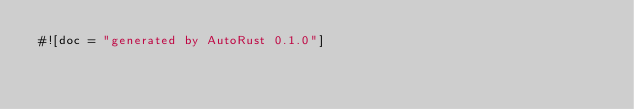<code> <loc_0><loc_0><loc_500><loc_500><_Rust_>#![doc = "generated by AutoRust 0.1.0"]</code> 